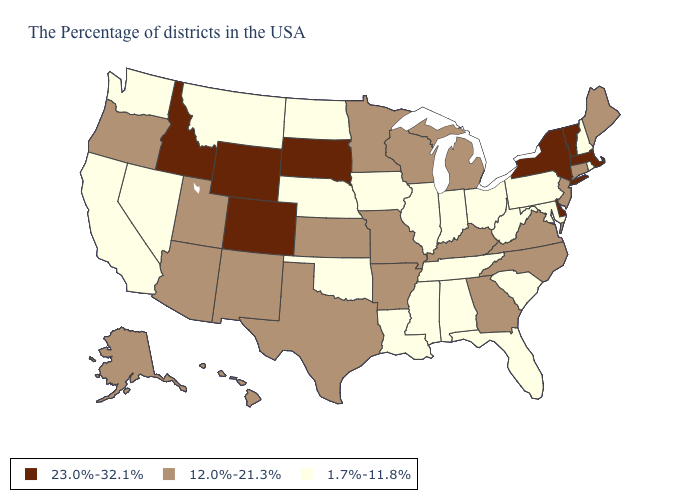Does Florida have the highest value in the USA?
Concise answer only. No. Name the states that have a value in the range 1.7%-11.8%?
Concise answer only. Rhode Island, New Hampshire, Maryland, Pennsylvania, South Carolina, West Virginia, Ohio, Florida, Indiana, Alabama, Tennessee, Illinois, Mississippi, Louisiana, Iowa, Nebraska, Oklahoma, North Dakota, Montana, Nevada, California, Washington. Does the first symbol in the legend represent the smallest category?
Short answer required. No. Does New Hampshire have a lower value than Texas?
Be succinct. Yes. Does South Dakota have the highest value in the MidWest?
Give a very brief answer. Yes. Does South Dakota have the highest value in the USA?
Keep it brief. Yes. Name the states that have a value in the range 1.7%-11.8%?
Answer briefly. Rhode Island, New Hampshire, Maryland, Pennsylvania, South Carolina, West Virginia, Ohio, Florida, Indiana, Alabama, Tennessee, Illinois, Mississippi, Louisiana, Iowa, Nebraska, Oklahoma, North Dakota, Montana, Nevada, California, Washington. What is the value of Arkansas?
Concise answer only. 12.0%-21.3%. Does the first symbol in the legend represent the smallest category?
Be succinct. No. Does Tennessee have the highest value in the USA?
Write a very short answer. No. What is the value of Idaho?
Give a very brief answer. 23.0%-32.1%. Is the legend a continuous bar?
Be succinct. No. What is the lowest value in the West?
Short answer required. 1.7%-11.8%. What is the lowest value in the Northeast?
Short answer required. 1.7%-11.8%. Does West Virginia have the lowest value in the USA?
Write a very short answer. Yes. 